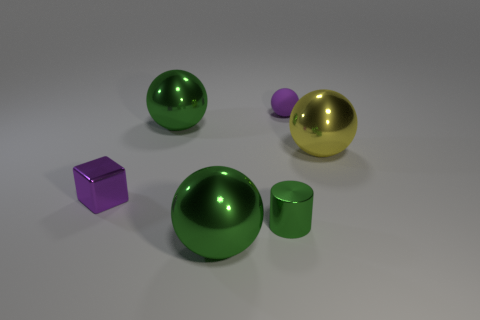Add 2 blue metallic balls. How many objects exist? 8 Subtract all cylinders. How many objects are left? 5 Add 5 shiny blocks. How many shiny blocks exist? 6 Subtract 0 blue cylinders. How many objects are left? 6 Subtract all tiny purple spheres. Subtract all small green shiny cylinders. How many objects are left? 4 Add 3 spheres. How many spheres are left? 7 